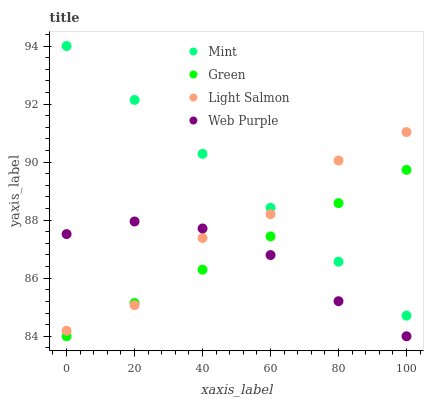Does Web Purple have the minimum area under the curve?
Answer yes or no. Yes. Does Mint have the maximum area under the curve?
Answer yes or no. Yes. Does Light Salmon have the minimum area under the curve?
Answer yes or no. No. Does Light Salmon have the maximum area under the curve?
Answer yes or no. No. Is Green the smoothest?
Answer yes or no. Yes. Is Light Salmon the roughest?
Answer yes or no. Yes. Is Mint the smoothest?
Answer yes or no. No. Is Mint the roughest?
Answer yes or no. No. Does Green have the lowest value?
Answer yes or no. Yes. Does Light Salmon have the lowest value?
Answer yes or no. No. Does Mint have the highest value?
Answer yes or no. Yes. Does Light Salmon have the highest value?
Answer yes or no. No. Is Web Purple less than Mint?
Answer yes or no. Yes. Is Mint greater than Web Purple?
Answer yes or no. Yes. Does Green intersect Mint?
Answer yes or no. Yes. Is Green less than Mint?
Answer yes or no. No. Is Green greater than Mint?
Answer yes or no. No. Does Web Purple intersect Mint?
Answer yes or no. No. 